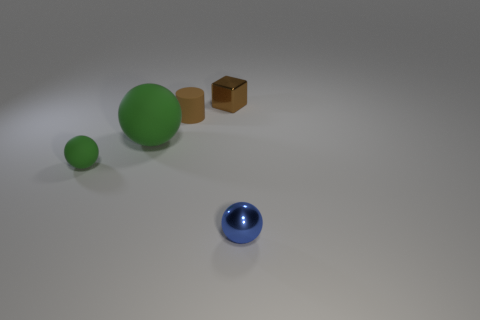Add 3 matte balls. How many objects exist? 8 Subtract all cylinders. How many objects are left? 4 Add 5 tiny cylinders. How many tiny cylinders exist? 6 Subtract 1 blue balls. How many objects are left? 4 Subtract all large yellow shiny cylinders. Subtract all blue balls. How many objects are left? 4 Add 5 small brown cubes. How many small brown cubes are left? 6 